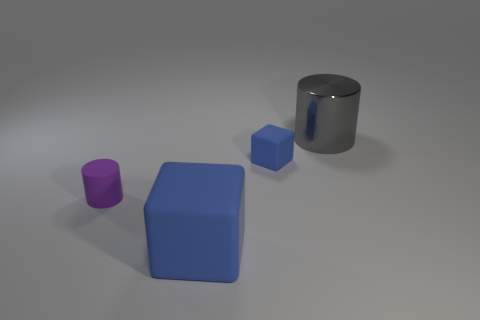Subtract all blue blocks. How many were subtracted if there are1blue blocks left? 1 Add 3 tiny yellow rubber spheres. How many objects exist? 7 Subtract all purple cylinders. How many cylinders are left? 1 Subtract 2 cylinders. How many cylinders are left? 0 Add 2 large blocks. How many large blocks exist? 3 Subtract 0 brown cylinders. How many objects are left? 4 Subtract all purple cylinders. Subtract all red cubes. How many cylinders are left? 1 Subtract all green matte cylinders. Subtract all gray cylinders. How many objects are left? 3 Add 3 gray metallic objects. How many gray metallic objects are left? 4 